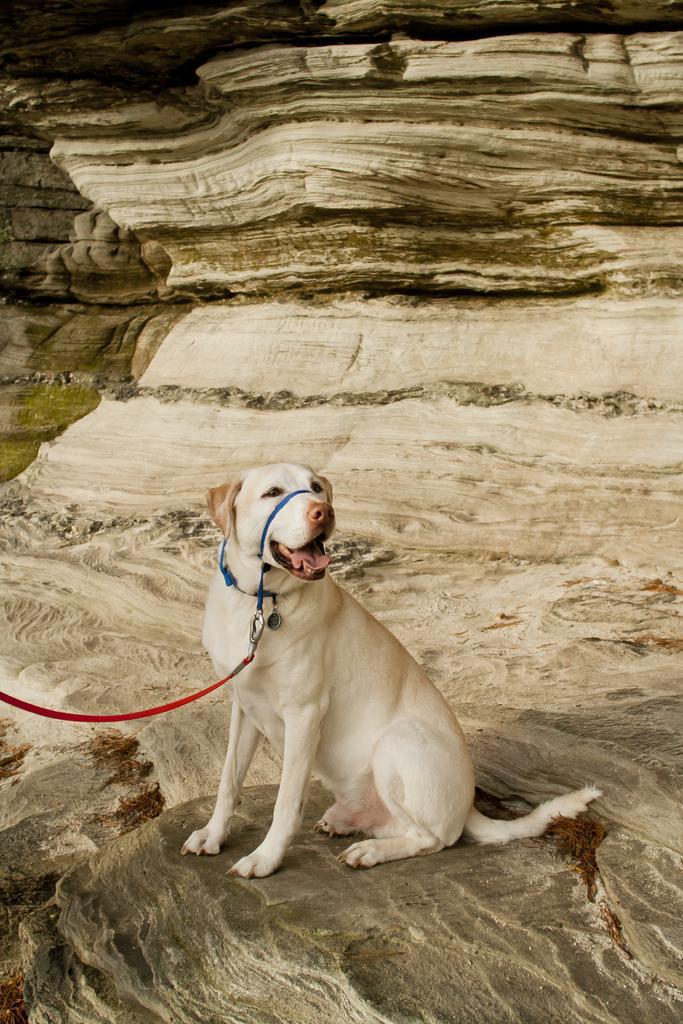How would you summarize this image in a sentence or two? In this picture I can see a dog, on the left side I can see the rope tied to this dog. In the background it looks like a stone. 